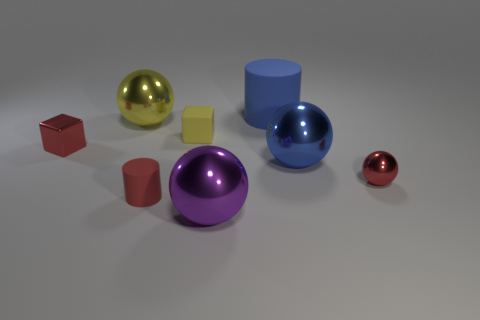Subtract 1 balls. How many balls are left? 3 Subtract all gray spheres. Subtract all green cylinders. How many spheres are left? 4 Add 2 large metallic balls. How many objects exist? 10 Subtract all cylinders. How many objects are left? 6 Subtract 0 green spheres. How many objects are left? 8 Subtract all big rubber cylinders. Subtract all rubber things. How many objects are left? 4 Add 8 yellow shiny things. How many yellow shiny things are left? 9 Add 3 large spheres. How many large spheres exist? 6 